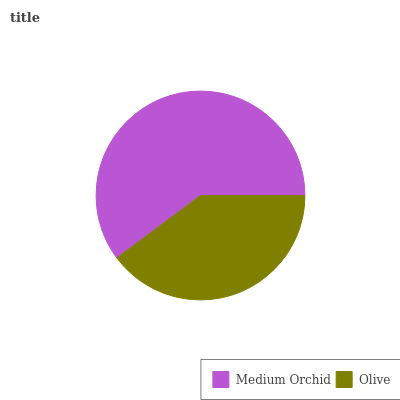Is Olive the minimum?
Answer yes or no. Yes. Is Medium Orchid the maximum?
Answer yes or no. Yes. Is Olive the maximum?
Answer yes or no. No. Is Medium Orchid greater than Olive?
Answer yes or no. Yes. Is Olive less than Medium Orchid?
Answer yes or no. Yes. Is Olive greater than Medium Orchid?
Answer yes or no. No. Is Medium Orchid less than Olive?
Answer yes or no. No. Is Medium Orchid the high median?
Answer yes or no. Yes. Is Olive the low median?
Answer yes or no. Yes. Is Olive the high median?
Answer yes or no. No. Is Medium Orchid the low median?
Answer yes or no. No. 